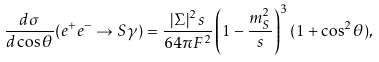<formula> <loc_0><loc_0><loc_500><loc_500>\frac { d \sigma } { d \cos \theta } ( e ^ { + } e ^ { - } \rightarrow S \gamma ) = \frac { \left | \Sigma \right | ^ { 2 } s } { 6 4 \pi F ^ { 2 } } \left ( 1 - \frac { m _ { S } ^ { 2 } } { s } \right ) ^ { 3 } ( 1 + \cos ^ { 2 } \theta ) ,</formula> 